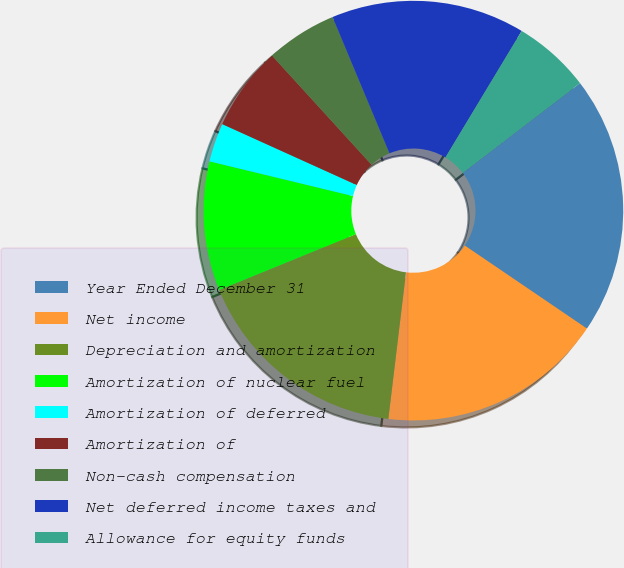Convert chart. <chart><loc_0><loc_0><loc_500><loc_500><pie_chart><fcel>Year Ended December 31<fcel>Net income<fcel>Depreciation and amortization<fcel>Amortization of nuclear fuel<fcel>Amortization of deferred<fcel>Amortization of<fcel>Non-cash compensation<fcel>Net deferred income taxes and<fcel>Allowance for equity funds<nl><fcel>19.9%<fcel>17.41%<fcel>16.92%<fcel>9.95%<fcel>2.99%<fcel>6.47%<fcel>5.47%<fcel>14.93%<fcel>5.97%<nl></chart> 